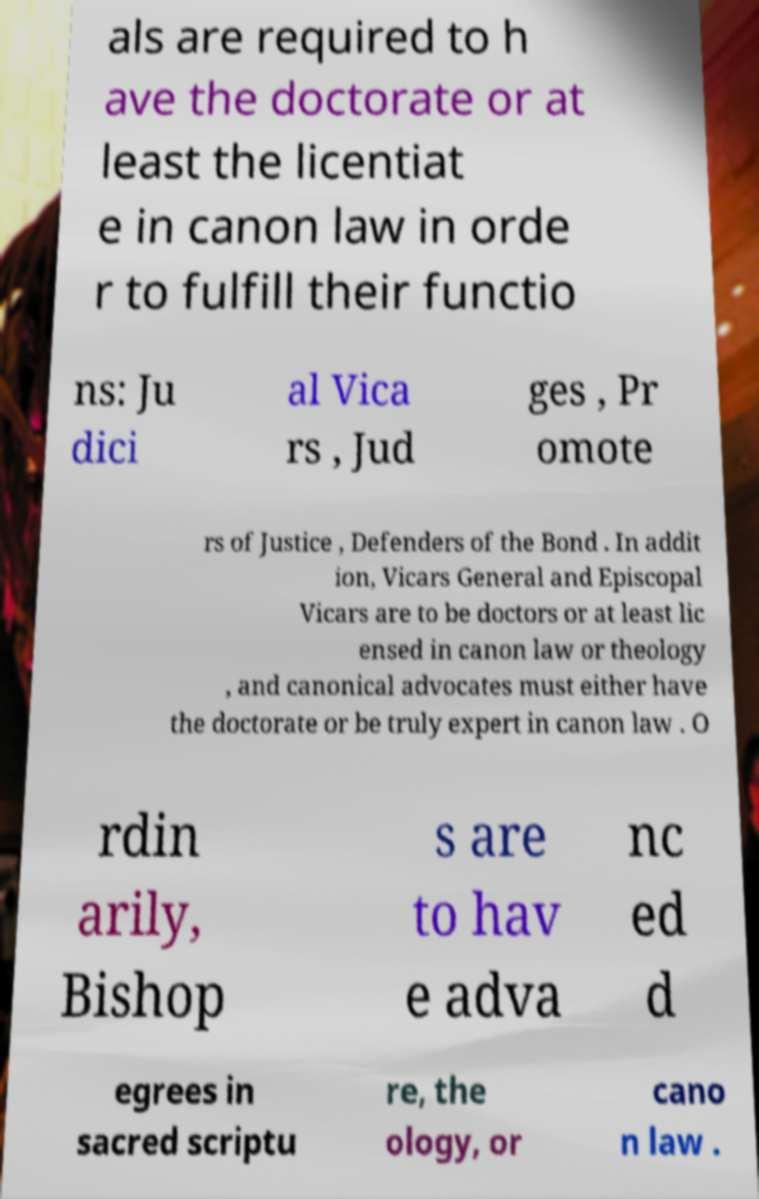There's text embedded in this image that I need extracted. Can you transcribe it verbatim? als are required to h ave the doctorate or at least the licentiat e in canon law in orde r to fulfill their functio ns: Ju dici al Vica rs , Jud ges , Pr omote rs of Justice , Defenders of the Bond . In addit ion, Vicars General and Episcopal Vicars are to be doctors or at least lic ensed in canon law or theology , and canonical advocates must either have the doctorate or be truly expert in canon law . O rdin arily, Bishop s are to hav e adva nc ed d egrees in sacred scriptu re, the ology, or cano n law . 